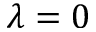<formula> <loc_0><loc_0><loc_500><loc_500>\lambda = 0</formula> 